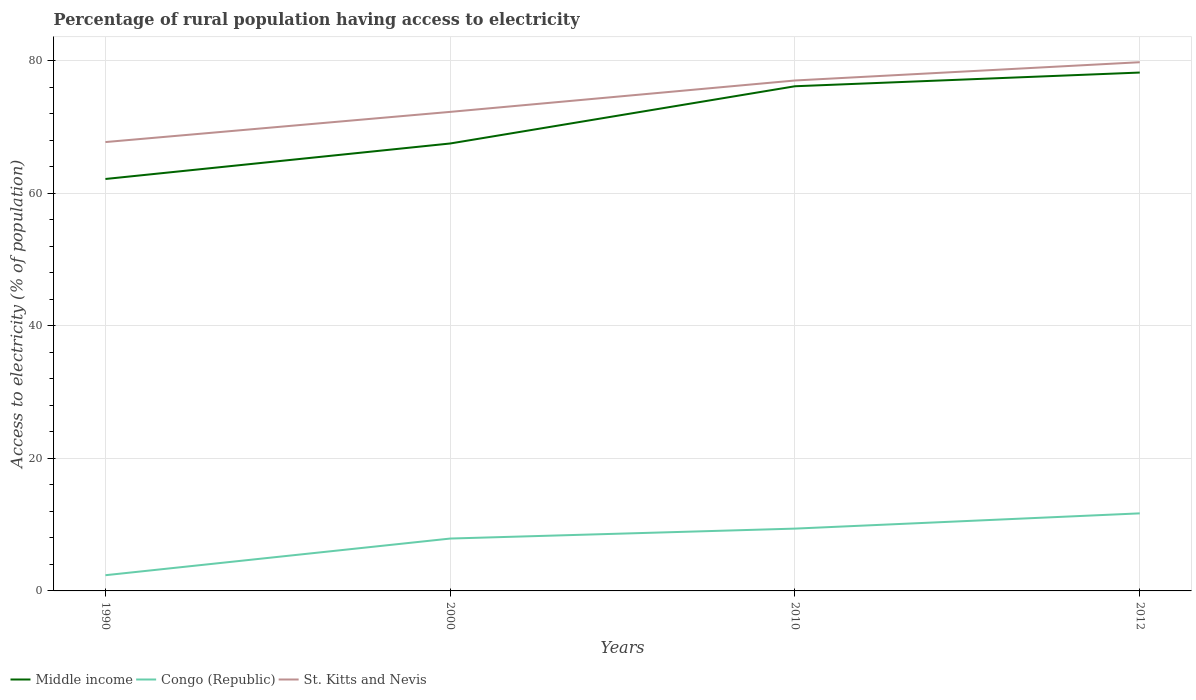How many different coloured lines are there?
Keep it short and to the point. 3. Does the line corresponding to St. Kitts and Nevis intersect with the line corresponding to Middle income?
Offer a very short reply. No. Is the number of lines equal to the number of legend labels?
Your answer should be compact. Yes. Across all years, what is the maximum percentage of rural population having access to electricity in St. Kitts and Nevis?
Your response must be concise. 67.71. In which year was the percentage of rural population having access to electricity in Congo (Republic) maximum?
Offer a very short reply. 1990. What is the total percentage of rural population having access to electricity in Middle income in the graph?
Ensure brevity in your answer.  -13.99. What is the difference between the highest and the second highest percentage of rural population having access to electricity in Congo (Republic)?
Make the answer very short. 9.33. How many lines are there?
Provide a succinct answer. 3. Does the graph contain any zero values?
Offer a terse response. No. Where does the legend appear in the graph?
Offer a terse response. Bottom left. What is the title of the graph?
Your answer should be compact. Percentage of rural population having access to electricity. Does "Iraq" appear as one of the legend labels in the graph?
Provide a short and direct response. No. What is the label or title of the Y-axis?
Keep it short and to the point. Access to electricity (% of population). What is the Access to electricity (% of population) of Middle income in 1990?
Give a very brief answer. 62.14. What is the Access to electricity (% of population) in Congo (Republic) in 1990?
Offer a terse response. 2.37. What is the Access to electricity (% of population) of St. Kitts and Nevis in 1990?
Offer a very short reply. 67.71. What is the Access to electricity (% of population) in Middle income in 2000?
Offer a terse response. 67.5. What is the Access to electricity (% of population) in Congo (Republic) in 2000?
Offer a very short reply. 7.9. What is the Access to electricity (% of population) in St. Kitts and Nevis in 2000?
Ensure brevity in your answer.  72.27. What is the Access to electricity (% of population) of Middle income in 2010?
Provide a succinct answer. 76.13. What is the Access to electricity (% of population) in Congo (Republic) in 2010?
Offer a very short reply. 9.4. What is the Access to electricity (% of population) in St. Kitts and Nevis in 2010?
Your answer should be compact. 77. What is the Access to electricity (% of population) of Middle income in 2012?
Keep it short and to the point. 78.2. What is the Access to electricity (% of population) of St. Kitts and Nevis in 2012?
Your answer should be very brief. 79.75. Across all years, what is the maximum Access to electricity (% of population) of Middle income?
Your answer should be compact. 78.2. Across all years, what is the maximum Access to electricity (% of population) of Congo (Republic)?
Ensure brevity in your answer.  11.7. Across all years, what is the maximum Access to electricity (% of population) in St. Kitts and Nevis?
Your answer should be compact. 79.75. Across all years, what is the minimum Access to electricity (% of population) in Middle income?
Provide a succinct answer. 62.14. Across all years, what is the minimum Access to electricity (% of population) of Congo (Republic)?
Your answer should be very brief. 2.37. Across all years, what is the minimum Access to electricity (% of population) in St. Kitts and Nevis?
Provide a succinct answer. 67.71. What is the total Access to electricity (% of population) in Middle income in the graph?
Ensure brevity in your answer.  283.97. What is the total Access to electricity (% of population) of Congo (Republic) in the graph?
Offer a very short reply. 31.37. What is the total Access to electricity (% of population) in St. Kitts and Nevis in the graph?
Keep it short and to the point. 296.73. What is the difference between the Access to electricity (% of population) in Middle income in 1990 and that in 2000?
Your answer should be very brief. -5.36. What is the difference between the Access to electricity (% of population) in Congo (Republic) in 1990 and that in 2000?
Keep it short and to the point. -5.53. What is the difference between the Access to electricity (% of population) in St. Kitts and Nevis in 1990 and that in 2000?
Provide a short and direct response. -4.55. What is the difference between the Access to electricity (% of population) of Middle income in 1990 and that in 2010?
Your answer should be very brief. -13.99. What is the difference between the Access to electricity (% of population) of Congo (Republic) in 1990 and that in 2010?
Offer a very short reply. -7.03. What is the difference between the Access to electricity (% of population) of St. Kitts and Nevis in 1990 and that in 2010?
Ensure brevity in your answer.  -9.29. What is the difference between the Access to electricity (% of population) in Middle income in 1990 and that in 2012?
Keep it short and to the point. -16.06. What is the difference between the Access to electricity (% of population) of Congo (Republic) in 1990 and that in 2012?
Provide a succinct answer. -9.33. What is the difference between the Access to electricity (% of population) in St. Kitts and Nevis in 1990 and that in 2012?
Offer a terse response. -12.04. What is the difference between the Access to electricity (% of population) in Middle income in 2000 and that in 2010?
Offer a very short reply. -8.63. What is the difference between the Access to electricity (% of population) in Congo (Republic) in 2000 and that in 2010?
Provide a succinct answer. -1.5. What is the difference between the Access to electricity (% of population) in St. Kitts and Nevis in 2000 and that in 2010?
Your answer should be very brief. -4.74. What is the difference between the Access to electricity (% of population) in Middle income in 2000 and that in 2012?
Offer a very short reply. -10.7. What is the difference between the Access to electricity (% of population) of St. Kitts and Nevis in 2000 and that in 2012?
Your answer should be compact. -7.49. What is the difference between the Access to electricity (% of population) of Middle income in 2010 and that in 2012?
Your response must be concise. -2.07. What is the difference between the Access to electricity (% of population) of Congo (Republic) in 2010 and that in 2012?
Make the answer very short. -2.3. What is the difference between the Access to electricity (% of population) of St. Kitts and Nevis in 2010 and that in 2012?
Provide a short and direct response. -2.75. What is the difference between the Access to electricity (% of population) of Middle income in 1990 and the Access to electricity (% of population) of Congo (Republic) in 2000?
Your answer should be compact. 54.24. What is the difference between the Access to electricity (% of population) of Middle income in 1990 and the Access to electricity (% of population) of St. Kitts and Nevis in 2000?
Offer a very short reply. -10.12. What is the difference between the Access to electricity (% of population) in Congo (Republic) in 1990 and the Access to electricity (% of population) in St. Kitts and Nevis in 2000?
Ensure brevity in your answer.  -69.9. What is the difference between the Access to electricity (% of population) of Middle income in 1990 and the Access to electricity (% of population) of Congo (Republic) in 2010?
Provide a succinct answer. 52.74. What is the difference between the Access to electricity (% of population) in Middle income in 1990 and the Access to electricity (% of population) in St. Kitts and Nevis in 2010?
Offer a terse response. -14.86. What is the difference between the Access to electricity (% of population) of Congo (Republic) in 1990 and the Access to electricity (% of population) of St. Kitts and Nevis in 2010?
Make the answer very short. -74.63. What is the difference between the Access to electricity (% of population) in Middle income in 1990 and the Access to electricity (% of population) in Congo (Republic) in 2012?
Offer a very short reply. 50.44. What is the difference between the Access to electricity (% of population) in Middle income in 1990 and the Access to electricity (% of population) in St. Kitts and Nevis in 2012?
Provide a short and direct response. -17.61. What is the difference between the Access to electricity (% of population) in Congo (Republic) in 1990 and the Access to electricity (% of population) in St. Kitts and Nevis in 2012?
Offer a terse response. -77.38. What is the difference between the Access to electricity (% of population) in Middle income in 2000 and the Access to electricity (% of population) in Congo (Republic) in 2010?
Your response must be concise. 58.1. What is the difference between the Access to electricity (% of population) in Middle income in 2000 and the Access to electricity (% of population) in St. Kitts and Nevis in 2010?
Give a very brief answer. -9.5. What is the difference between the Access to electricity (% of population) in Congo (Republic) in 2000 and the Access to electricity (% of population) in St. Kitts and Nevis in 2010?
Provide a succinct answer. -69.1. What is the difference between the Access to electricity (% of population) of Middle income in 2000 and the Access to electricity (% of population) of Congo (Republic) in 2012?
Your answer should be very brief. 55.8. What is the difference between the Access to electricity (% of population) in Middle income in 2000 and the Access to electricity (% of population) in St. Kitts and Nevis in 2012?
Provide a succinct answer. -12.26. What is the difference between the Access to electricity (% of population) in Congo (Republic) in 2000 and the Access to electricity (% of population) in St. Kitts and Nevis in 2012?
Offer a terse response. -71.85. What is the difference between the Access to electricity (% of population) of Middle income in 2010 and the Access to electricity (% of population) of Congo (Republic) in 2012?
Offer a very short reply. 64.43. What is the difference between the Access to electricity (% of population) of Middle income in 2010 and the Access to electricity (% of population) of St. Kitts and Nevis in 2012?
Offer a terse response. -3.62. What is the difference between the Access to electricity (% of population) of Congo (Republic) in 2010 and the Access to electricity (% of population) of St. Kitts and Nevis in 2012?
Ensure brevity in your answer.  -70.35. What is the average Access to electricity (% of population) of Middle income per year?
Give a very brief answer. 70.99. What is the average Access to electricity (% of population) of Congo (Republic) per year?
Provide a succinct answer. 7.84. What is the average Access to electricity (% of population) of St. Kitts and Nevis per year?
Your answer should be very brief. 74.18. In the year 1990, what is the difference between the Access to electricity (% of population) in Middle income and Access to electricity (% of population) in Congo (Republic)?
Your answer should be compact. 59.77. In the year 1990, what is the difference between the Access to electricity (% of population) of Middle income and Access to electricity (% of population) of St. Kitts and Nevis?
Your answer should be compact. -5.57. In the year 1990, what is the difference between the Access to electricity (% of population) of Congo (Republic) and Access to electricity (% of population) of St. Kitts and Nevis?
Keep it short and to the point. -65.34. In the year 2000, what is the difference between the Access to electricity (% of population) of Middle income and Access to electricity (% of population) of Congo (Republic)?
Your response must be concise. 59.6. In the year 2000, what is the difference between the Access to electricity (% of population) in Middle income and Access to electricity (% of population) in St. Kitts and Nevis?
Offer a terse response. -4.77. In the year 2000, what is the difference between the Access to electricity (% of population) in Congo (Republic) and Access to electricity (% of population) in St. Kitts and Nevis?
Your answer should be very brief. -64.36. In the year 2010, what is the difference between the Access to electricity (% of population) in Middle income and Access to electricity (% of population) in Congo (Republic)?
Offer a terse response. 66.73. In the year 2010, what is the difference between the Access to electricity (% of population) in Middle income and Access to electricity (% of population) in St. Kitts and Nevis?
Provide a short and direct response. -0.87. In the year 2010, what is the difference between the Access to electricity (% of population) of Congo (Republic) and Access to electricity (% of population) of St. Kitts and Nevis?
Keep it short and to the point. -67.6. In the year 2012, what is the difference between the Access to electricity (% of population) in Middle income and Access to electricity (% of population) in Congo (Republic)?
Your answer should be compact. 66.5. In the year 2012, what is the difference between the Access to electricity (% of population) of Middle income and Access to electricity (% of population) of St. Kitts and Nevis?
Provide a succinct answer. -1.56. In the year 2012, what is the difference between the Access to electricity (% of population) in Congo (Republic) and Access to electricity (% of population) in St. Kitts and Nevis?
Keep it short and to the point. -68.05. What is the ratio of the Access to electricity (% of population) in Middle income in 1990 to that in 2000?
Ensure brevity in your answer.  0.92. What is the ratio of the Access to electricity (% of population) in Congo (Republic) in 1990 to that in 2000?
Provide a succinct answer. 0.3. What is the ratio of the Access to electricity (% of population) of St. Kitts and Nevis in 1990 to that in 2000?
Provide a succinct answer. 0.94. What is the ratio of the Access to electricity (% of population) of Middle income in 1990 to that in 2010?
Your response must be concise. 0.82. What is the ratio of the Access to electricity (% of population) of Congo (Republic) in 1990 to that in 2010?
Provide a succinct answer. 0.25. What is the ratio of the Access to electricity (% of population) in St. Kitts and Nevis in 1990 to that in 2010?
Give a very brief answer. 0.88. What is the ratio of the Access to electricity (% of population) in Middle income in 1990 to that in 2012?
Provide a succinct answer. 0.79. What is the ratio of the Access to electricity (% of population) of Congo (Republic) in 1990 to that in 2012?
Your answer should be very brief. 0.2. What is the ratio of the Access to electricity (% of population) in St. Kitts and Nevis in 1990 to that in 2012?
Your answer should be very brief. 0.85. What is the ratio of the Access to electricity (% of population) of Middle income in 2000 to that in 2010?
Give a very brief answer. 0.89. What is the ratio of the Access to electricity (% of population) in Congo (Republic) in 2000 to that in 2010?
Provide a succinct answer. 0.84. What is the ratio of the Access to electricity (% of population) of St. Kitts and Nevis in 2000 to that in 2010?
Your answer should be compact. 0.94. What is the ratio of the Access to electricity (% of population) in Middle income in 2000 to that in 2012?
Provide a short and direct response. 0.86. What is the ratio of the Access to electricity (% of population) in Congo (Republic) in 2000 to that in 2012?
Make the answer very short. 0.68. What is the ratio of the Access to electricity (% of population) in St. Kitts and Nevis in 2000 to that in 2012?
Provide a succinct answer. 0.91. What is the ratio of the Access to electricity (% of population) of Middle income in 2010 to that in 2012?
Ensure brevity in your answer.  0.97. What is the ratio of the Access to electricity (% of population) of Congo (Republic) in 2010 to that in 2012?
Your response must be concise. 0.8. What is the ratio of the Access to electricity (% of population) in St. Kitts and Nevis in 2010 to that in 2012?
Give a very brief answer. 0.97. What is the difference between the highest and the second highest Access to electricity (% of population) in Middle income?
Ensure brevity in your answer.  2.07. What is the difference between the highest and the second highest Access to electricity (% of population) of Congo (Republic)?
Offer a terse response. 2.3. What is the difference between the highest and the second highest Access to electricity (% of population) of St. Kitts and Nevis?
Keep it short and to the point. 2.75. What is the difference between the highest and the lowest Access to electricity (% of population) of Middle income?
Ensure brevity in your answer.  16.06. What is the difference between the highest and the lowest Access to electricity (% of population) of Congo (Republic)?
Offer a terse response. 9.33. What is the difference between the highest and the lowest Access to electricity (% of population) of St. Kitts and Nevis?
Keep it short and to the point. 12.04. 